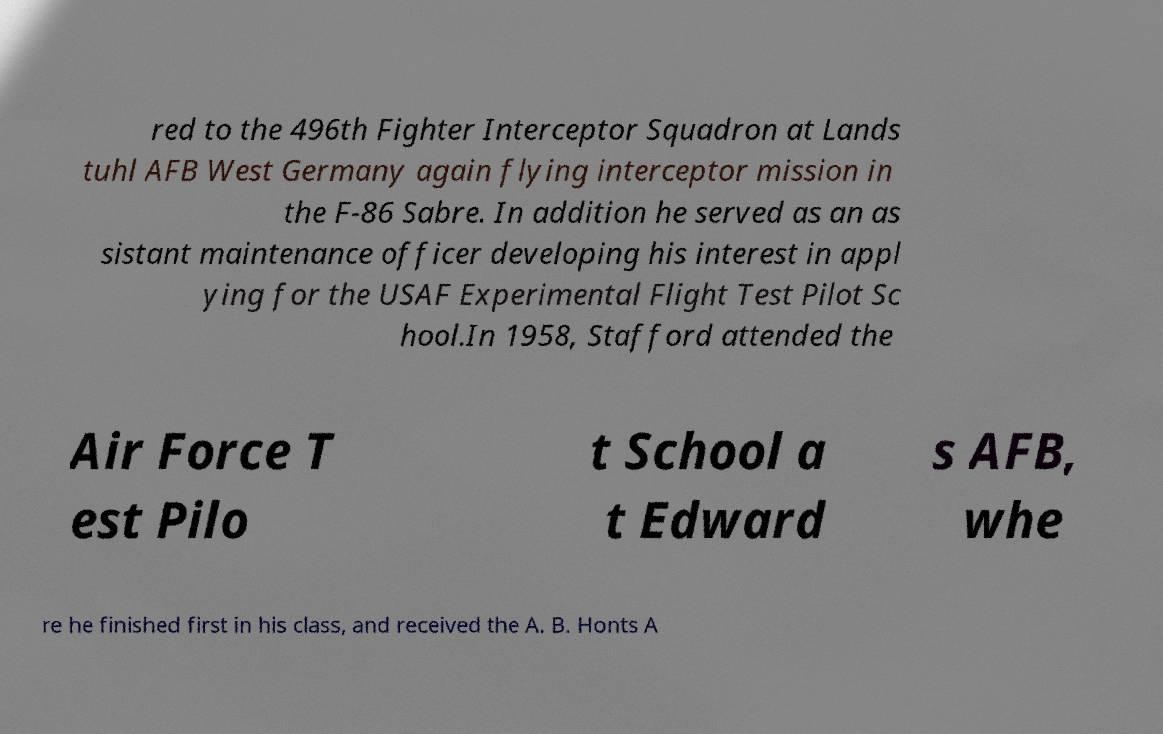What messages or text are displayed in this image? I need them in a readable, typed format. red to the 496th Fighter Interceptor Squadron at Lands tuhl AFB West Germany again flying interceptor mission in the F-86 Sabre. In addition he served as an as sistant maintenance officer developing his interest in appl ying for the USAF Experimental Flight Test Pilot Sc hool.In 1958, Stafford attended the Air Force T est Pilo t School a t Edward s AFB, whe re he finished first in his class, and received the A. B. Honts A 